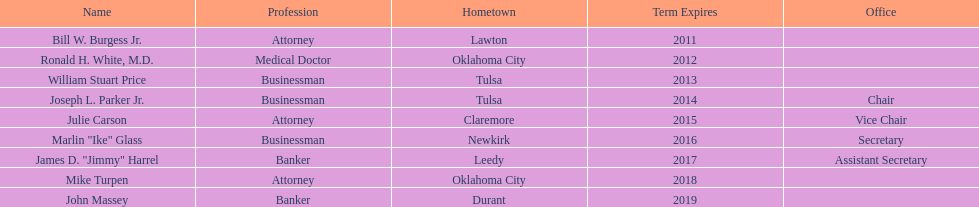In which state will the regent's term have the longest duration? John Massey. 